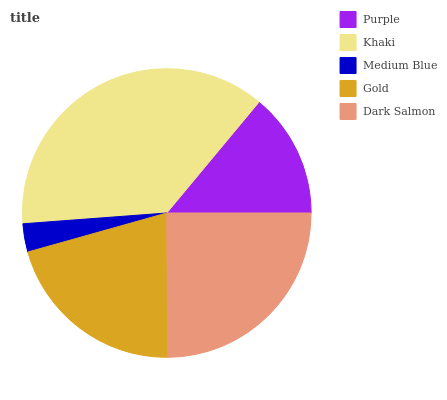Is Medium Blue the minimum?
Answer yes or no. Yes. Is Khaki the maximum?
Answer yes or no. Yes. Is Khaki the minimum?
Answer yes or no. No. Is Medium Blue the maximum?
Answer yes or no. No. Is Khaki greater than Medium Blue?
Answer yes or no. Yes. Is Medium Blue less than Khaki?
Answer yes or no. Yes. Is Medium Blue greater than Khaki?
Answer yes or no. No. Is Khaki less than Medium Blue?
Answer yes or no. No. Is Gold the high median?
Answer yes or no. Yes. Is Gold the low median?
Answer yes or no. Yes. Is Purple the high median?
Answer yes or no. No. Is Dark Salmon the low median?
Answer yes or no. No. 